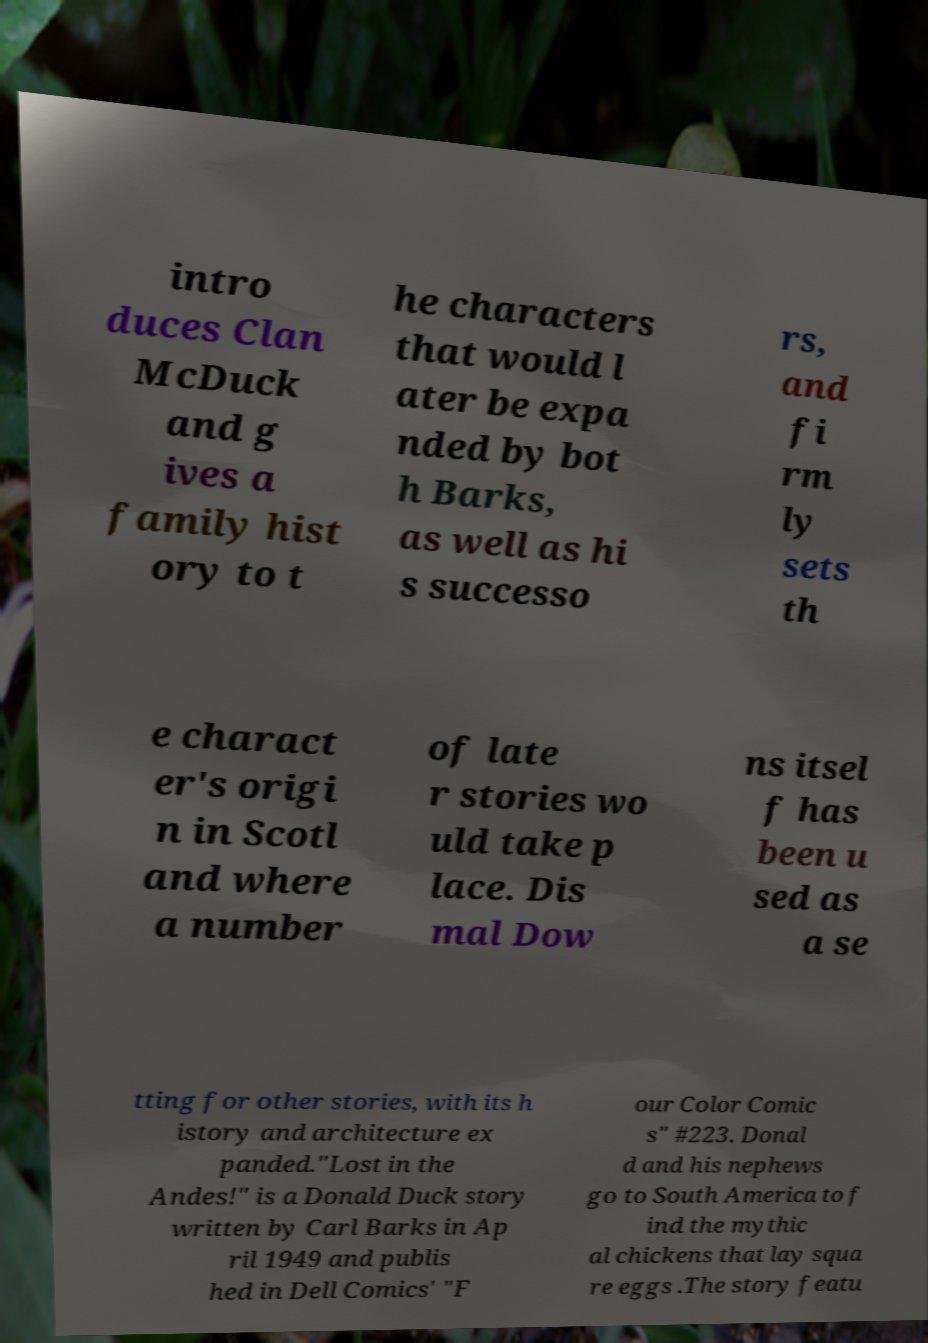Please identify and transcribe the text found in this image. intro duces Clan McDuck and g ives a family hist ory to t he characters that would l ater be expa nded by bot h Barks, as well as hi s successo rs, and fi rm ly sets th e charact er's origi n in Scotl and where a number of late r stories wo uld take p lace. Dis mal Dow ns itsel f has been u sed as a se tting for other stories, with its h istory and architecture ex panded."Lost in the Andes!" is a Donald Duck story written by Carl Barks in Ap ril 1949 and publis hed in Dell Comics' "F our Color Comic s" #223. Donal d and his nephews go to South America to f ind the mythic al chickens that lay squa re eggs .The story featu 